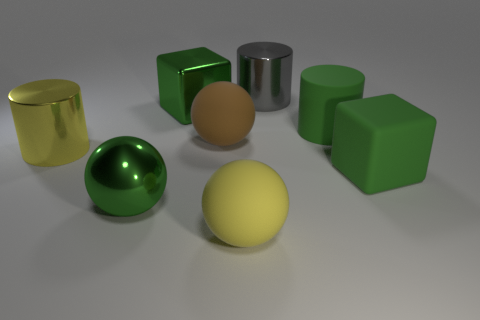What is the material of the brown object that is the same size as the yellow metallic cylinder?
Offer a terse response. Rubber. Do the yellow ball and the large gray thing have the same material?
Offer a very short reply. No. What number of yellow things have the same material as the large yellow cylinder?
Ensure brevity in your answer.  0. How many things are large matte balls behind the large yellow sphere or balls that are behind the big yellow shiny thing?
Keep it short and to the point. 1. Is the number of big rubber cylinders right of the green rubber block greater than the number of yellow shiny cylinders that are on the right side of the large yellow metal cylinder?
Provide a short and direct response. No. There is a large cylinder to the left of the gray metal cylinder; what is its color?
Your answer should be compact. Yellow. Is there a large gray thing of the same shape as the brown matte object?
Ensure brevity in your answer.  No. How many green things are either metal cubes or cubes?
Your answer should be very brief. 2. Are there any blocks of the same size as the yellow matte object?
Give a very brief answer. Yes. How many tiny purple metallic blocks are there?
Your answer should be compact. 0. 